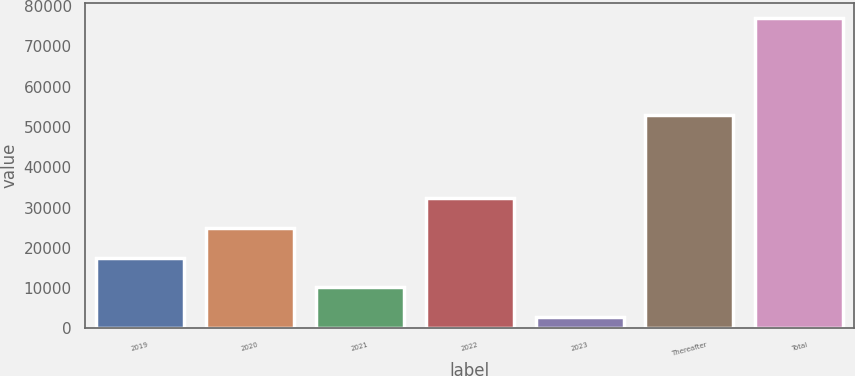<chart> <loc_0><loc_0><loc_500><loc_500><bar_chart><fcel>2019<fcel>2020<fcel>2021<fcel>2022<fcel>2023<fcel>Thereafter<fcel>Total<nl><fcel>17579.6<fcel>24994.4<fcel>10164.8<fcel>32409.2<fcel>2750<fcel>52836<fcel>76898<nl></chart> 